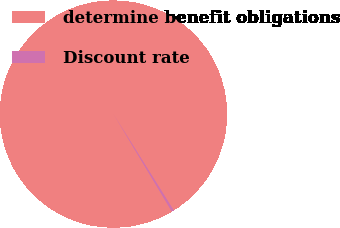<chart> <loc_0><loc_0><loc_500><loc_500><pie_chart><fcel>determine benefit obligations<fcel>Discount rate<nl><fcel>99.69%<fcel>0.31%<nl></chart> 